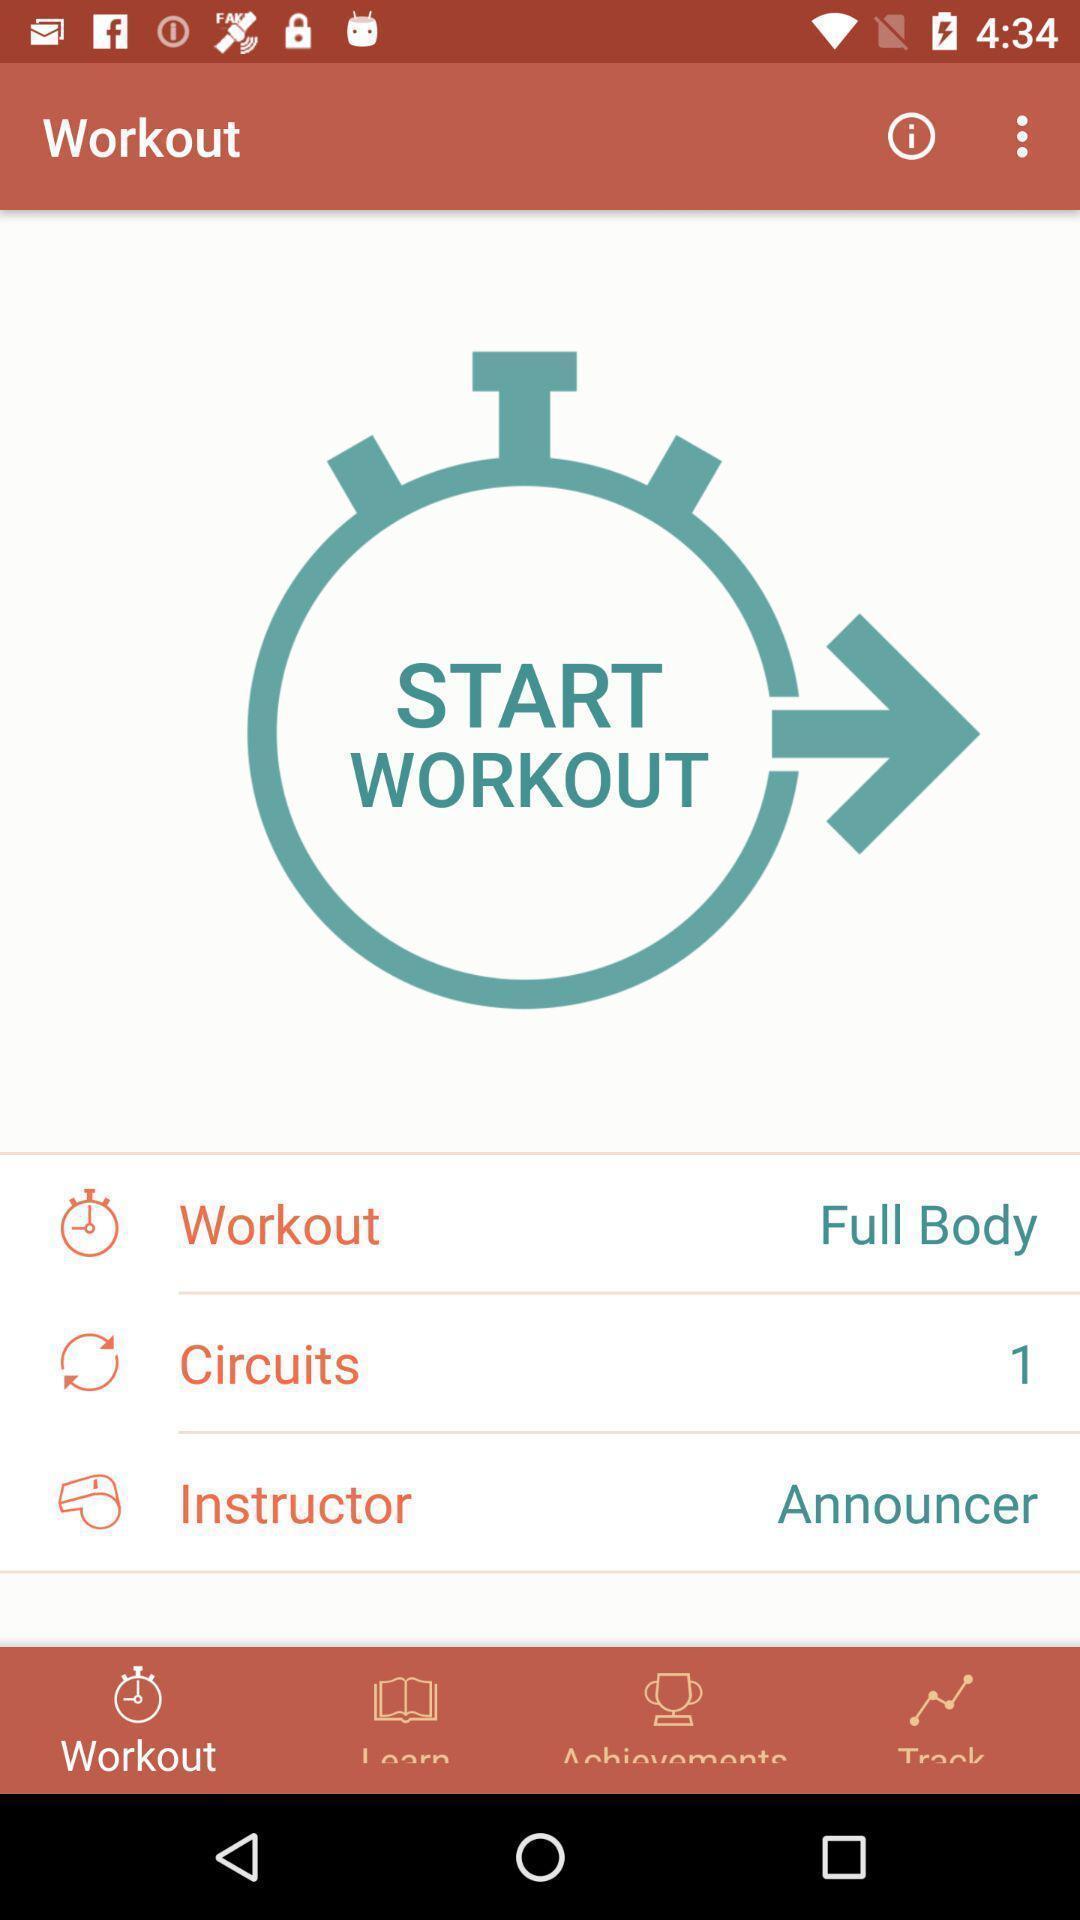Summarize the information in this screenshot. Timer and different features of a fitness app are displaying. 